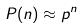Convert formula to latex. <formula><loc_0><loc_0><loc_500><loc_500>P ( n ) \approx p ^ { n }</formula> 